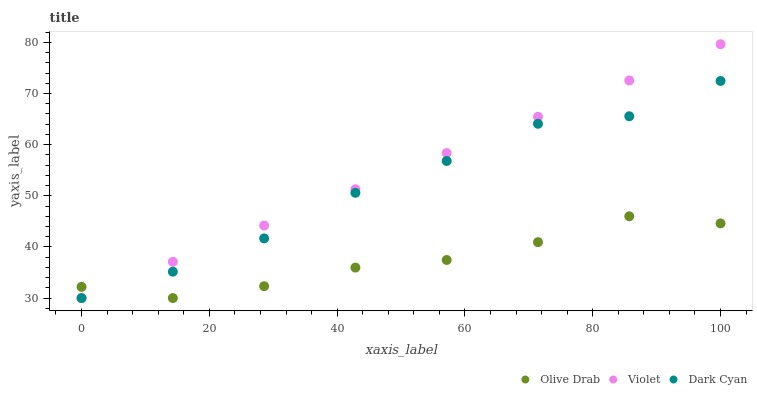Does Olive Drab have the minimum area under the curve?
Answer yes or no. Yes. Does Violet have the maximum area under the curve?
Answer yes or no. Yes. Does Violet have the minimum area under the curve?
Answer yes or no. No. Does Olive Drab have the maximum area under the curve?
Answer yes or no. No. Is Violet the smoothest?
Answer yes or no. Yes. Is Dark Cyan the roughest?
Answer yes or no. Yes. Is Olive Drab the smoothest?
Answer yes or no. No. Is Olive Drab the roughest?
Answer yes or no. No. Does Dark Cyan have the lowest value?
Answer yes or no. Yes. Does Violet have the highest value?
Answer yes or no. Yes. Does Olive Drab have the highest value?
Answer yes or no. No. Does Olive Drab intersect Dark Cyan?
Answer yes or no. Yes. Is Olive Drab less than Dark Cyan?
Answer yes or no. No. Is Olive Drab greater than Dark Cyan?
Answer yes or no. No. 